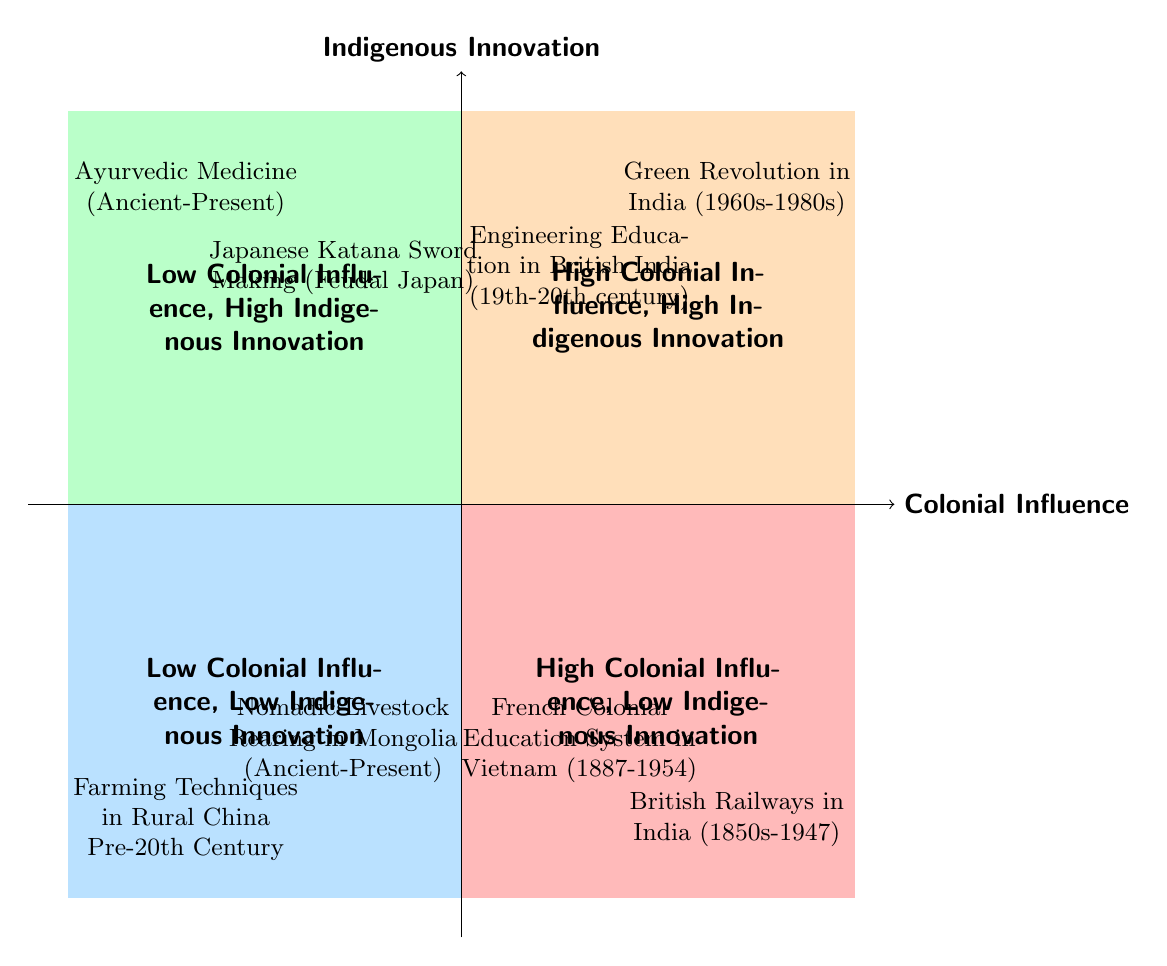What's in Quadrant 1? Quadrant 1 has the title "High Colonial Influence, High Indigenous Innovation." The examples listed here include "Green Revolution in India" and "Engineering Education in British India."
Answer: Green Revolution in India, Engineering Education in British India How many examples are in Quadrant 3? Quadrant 3 displays two examples: "British Railways in India" and "French Colonial Education System in Vietnam." Therefore, the total number of examples in this quadrant is two.
Answer: 2 What period is associated with Ayurvedic Medicine? The information listed under Ayurvedic Medicine states that its period spans from "Ancient-Present." This is clearly specified in the example.
Answer: Ancient-Present Which quadrant contains the Japanese Katana Sword Making example? The Japanese Katana Sword Making is included in Quadrant 2, which is characterized by "Low Colonial Influence, High Indigenous Innovation." This placement directly indicates its context.
Answer: Quadrant 2 Is there an example of "High Colonial Influence, Low Indigenous Innovation"? Yes, the "British Railways in India" serves as the example for "High Colonial Influence, Low Indigenous Innovation." This is indicated in Quadrant 3.
Answer: Yes What distinguishes Quadrant 4 from others? Quadrant 4 is titled "Low Colonial Influence, Low Indigenous Innovation," and it includes examples with minimal foreign influence and limited local innovation, illustrated by "Farming Techniques in Rural China Pre-20th Century" and "Nomadic Livestock Rearing in Mongolia."
Answer: Low Colonial Influence, Low Indigenous Innovation Which example had minimal direct colonial impact? The "Ayurvedic Medicine" is specified as having minimal direct colonial impact, thus fitting this description in Quadrant 2.
Answer: Ayurvedic Medicine What innovation occurred with the Green Revolution in India? The Green Revolution in India involved the integration of traditional farming knowledge and practices along with the introduction of Western technologies. This highlights the dual influence in this quadrant.
Answer: Integration of traditional farming knowledge and practices 